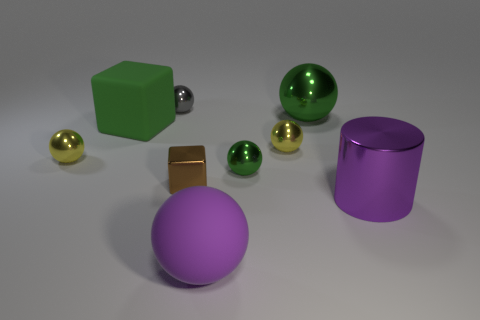Subtract all green spheres. How many spheres are left? 4 Subtract all green metal balls. How many balls are left? 4 Subtract 2 balls. How many balls are left? 4 Subtract all gray balls. Subtract all blue cylinders. How many balls are left? 5 Add 1 yellow metallic objects. How many objects exist? 10 Subtract all balls. How many objects are left? 3 Add 1 brown metallic blocks. How many brown metallic blocks are left? 2 Add 3 green things. How many green things exist? 6 Subtract 0 purple blocks. How many objects are left? 9 Subtract all big rubber blocks. Subtract all metal things. How many objects are left? 1 